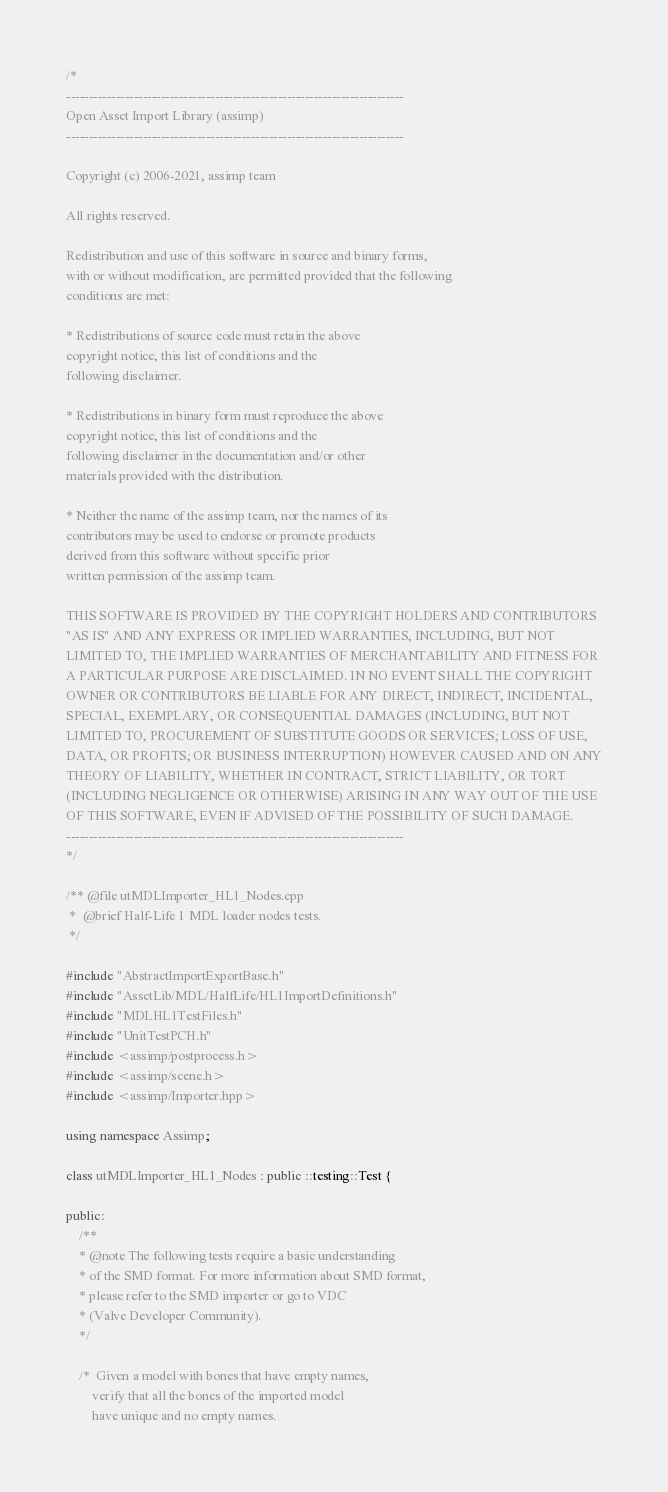<code> <loc_0><loc_0><loc_500><loc_500><_C++_>/*
---------------------------------------------------------------------------
Open Asset Import Library (assimp)
---------------------------------------------------------------------------

Copyright (c) 2006-2021, assimp team

All rights reserved.

Redistribution and use of this software in source and binary forms,
with or without modification, are permitted provided that the following
conditions are met:

* Redistributions of source code must retain the above
copyright notice, this list of conditions and the
following disclaimer.

* Redistributions in binary form must reproduce the above
copyright notice, this list of conditions and the
following disclaimer in the documentation and/or other
materials provided with the distribution.

* Neither the name of the assimp team, nor the names of its
contributors may be used to endorse or promote products
derived from this software without specific prior
written permission of the assimp team.

THIS SOFTWARE IS PROVIDED BY THE COPYRIGHT HOLDERS AND CONTRIBUTORS
"AS IS" AND ANY EXPRESS OR IMPLIED WARRANTIES, INCLUDING, BUT NOT
LIMITED TO, THE IMPLIED WARRANTIES OF MERCHANTABILITY AND FITNESS FOR
A PARTICULAR PURPOSE ARE DISCLAIMED. IN NO EVENT SHALL THE COPYRIGHT
OWNER OR CONTRIBUTORS BE LIABLE FOR ANY DIRECT, INDIRECT, INCIDENTAL,
SPECIAL, EXEMPLARY, OR CONSEQUENTIAL DAMAGES (INCLUDING, BUT NOT
LIMITED TO, PROCUREMENT OF SUBSTITUTE GOODS OR SERVICES; LOSS OF USE,
DATA, OR PROFITS; OR BUSINESS INTERRUPTION) HOWEVER CAUSED AND ON ANY
THEORY OF LIABILITY, WHETHER IN CONTRACT, STRICT LIABILITY, OR TORT
(INCLUDING NEGLIGENCE OR OTHERWISE) ARISING IN ANY WAY OUT OF THE USE
OF THIS SOFTWARE, EVEN IF ADVISED OF THE POSSIBILITY OF SUCH DAMAGE.
---------------------------------------------------------------------------
*/

/** @file utMDLImporter_HL1_Nodes.cpp
 *  @brief Half-Life 1 MDL loader nodes tests.
 */

#include "AbstractImportExportBase.h"
#include "AssetLib/MDL/HalfLife/HL1ImportDefinitions.h"
#include "MDLHL1TestFiles.h"
#include "UnitTestPCH.h"
#include <assimp/postprocess.h>
#include <assimp/scene.h>
#include <assimp/Importer.hpp>

using namespace Assimp;

class utMDLImporter_HL1_Nodes : public ::testing::Test {

public:
    /**
    * @note The following tests require a basic understanding
    * of the SMD format. For more information about SMD format,
    * please refer to the SMD importer or go to VDC
    * (Valve Developer Community).
    */

    /*  Given a model with bones that have empty names,
        verify that all the bones of the imported model
        have unique and no empty names.
</code> 